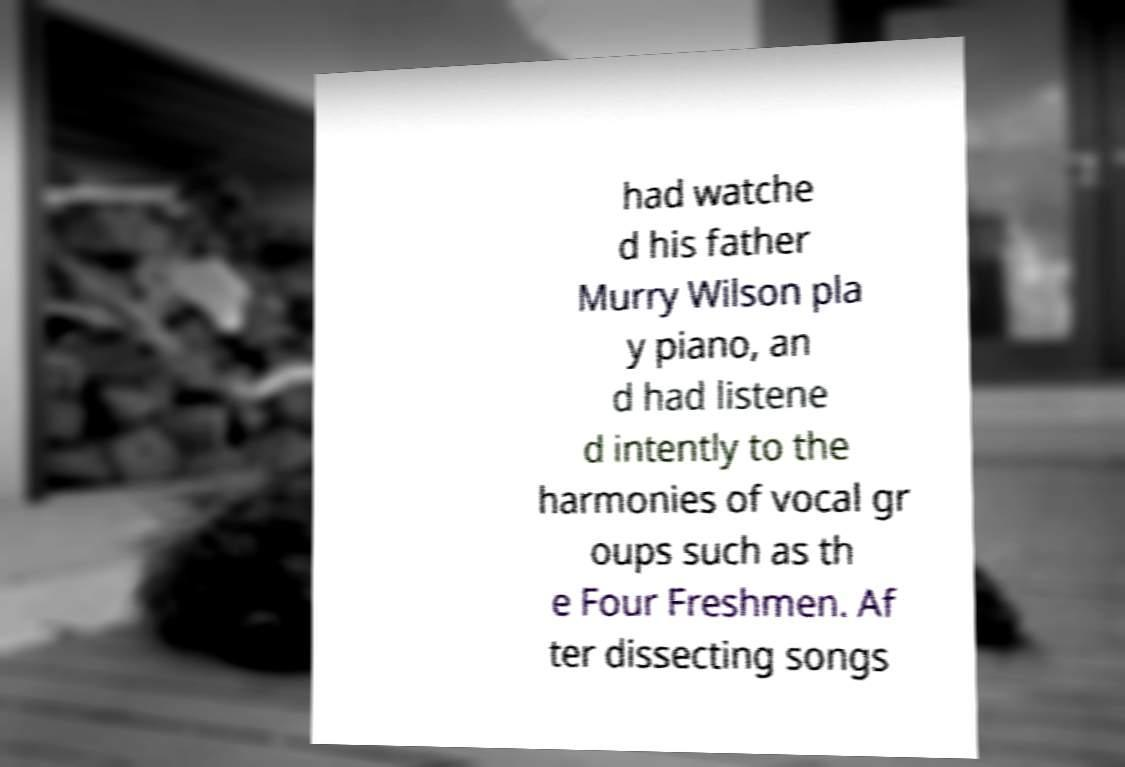Could you extract and type out the text from this image? had watche d his father Murry Wilson pla y piano, an d had listene d intently to the harmonies of vocal gr oups such as th e Four Freshmen. Af ter dissecting songs 